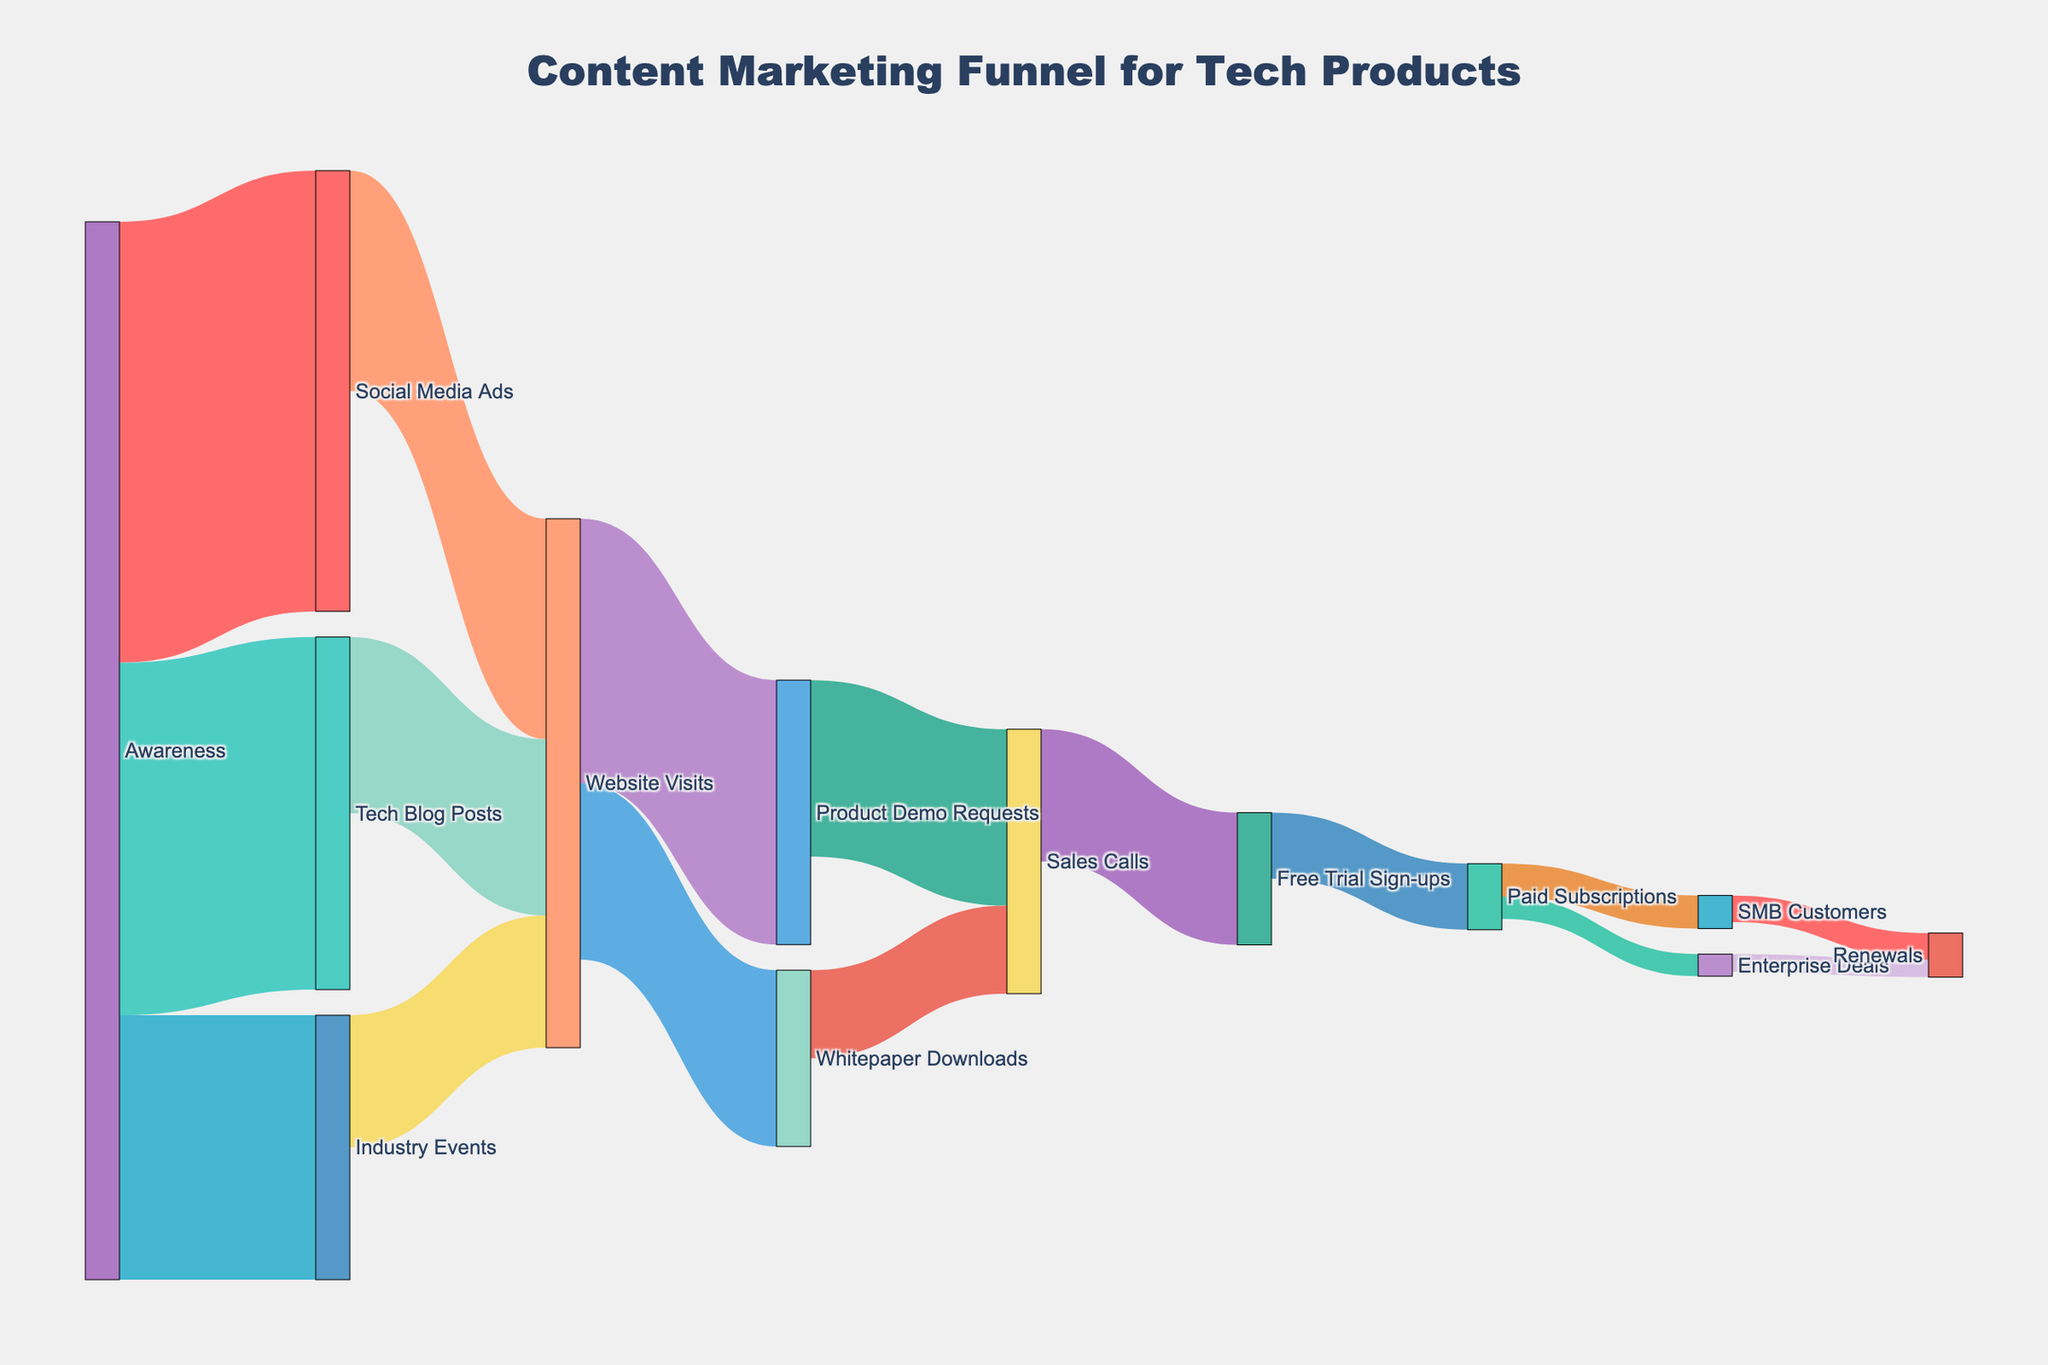What is the title of the figure? The title is prominently displayed at the top of the figure. It reads "Content Marketing Funnel for Tech Products."
Answer: Content Marketing Funnel for Tech Products How many pathways originate from 'Awareness'? To determine how many pathways originate from 'Awareness', count the number of flows starting from the 'Awareness' node. There are three pathways: to 'Social Media Ads', 'Tech Blog Posts', and 'Industry Events'.
Answer: Three Which channel contributes the most to 'Website Visits'? To find the highest contributor to 'Website Visits', compare the values from 'Social Media Ads', 'Tech Blog Posts', and 'Industry Events'. 'Social Media Ads' contributes 500, 'Tech Blog Posts' 400, and 'Industry Events' 300. Therefore, 'Social Media Ads' is the highest contributor.
Answer: Social Media Ads What is the total number of 'Website Visits'? Add the contributions from 'Social Media Ads', 'Tech Blog Posts', and 'Industry Events' that lead to 'Website Visits'. The total is 500 + 400 + 300 = 1200.
Answer: 1200 What percentage of 'Website Visits' result in 'Product Demo Requests'? First, determine the number of 'Product Demo Requests' from 'Website Visits', which is 600. Then, use the total number of 'Website Visits', which is 1200, to calculate the percentage: (600 / 1200) * 100 = 50%.
Answer: 50% How many 'Sales Calls' come from 'Product Demo Requests'? From the diagram, observe the value of the link from 'Product Demo Requests' to 'Sales Calls'. The value is 400.
Answer: 400 What is the conversion rate from 'Product Demo Requests' to 'Free Trial Sign-ups'? Determine the values for 'Product Demo Requests' (600) and 'Free Trial Sign-ups' (300). Then, calculate the conversion rate: (300 / 600) * 100%.
Answer: 50% How many pathways lead to 'Renewals'? Identify all the pathways that culminate in 'Renewals'. There are two pathways: 'Enterprise Deals' to 'Renewals' and 'SMB Customers' to 'Renewals'.
Answer: Two Which stage sees the highest drop-off in the funnel? Look for the stage with the greatest numerical difference between two connected nodes. The drop-off happens from 'Awareness' to 'Social Media Ads' (1000 to 500), a 500-unit drop. No other stage has a higher drop.
Answer: Awareness to Social Media Ads What is the combined number of 'Free Trial Sign-ups' and 'Paid Subscriptions'? Sum the values of 'Free Trial Sign-ups' and 'Paid Subscriptions'. The values are 300 and 150 respectively. Therefore, the combined number is 300 + 150 = 450.
Answer: 450 